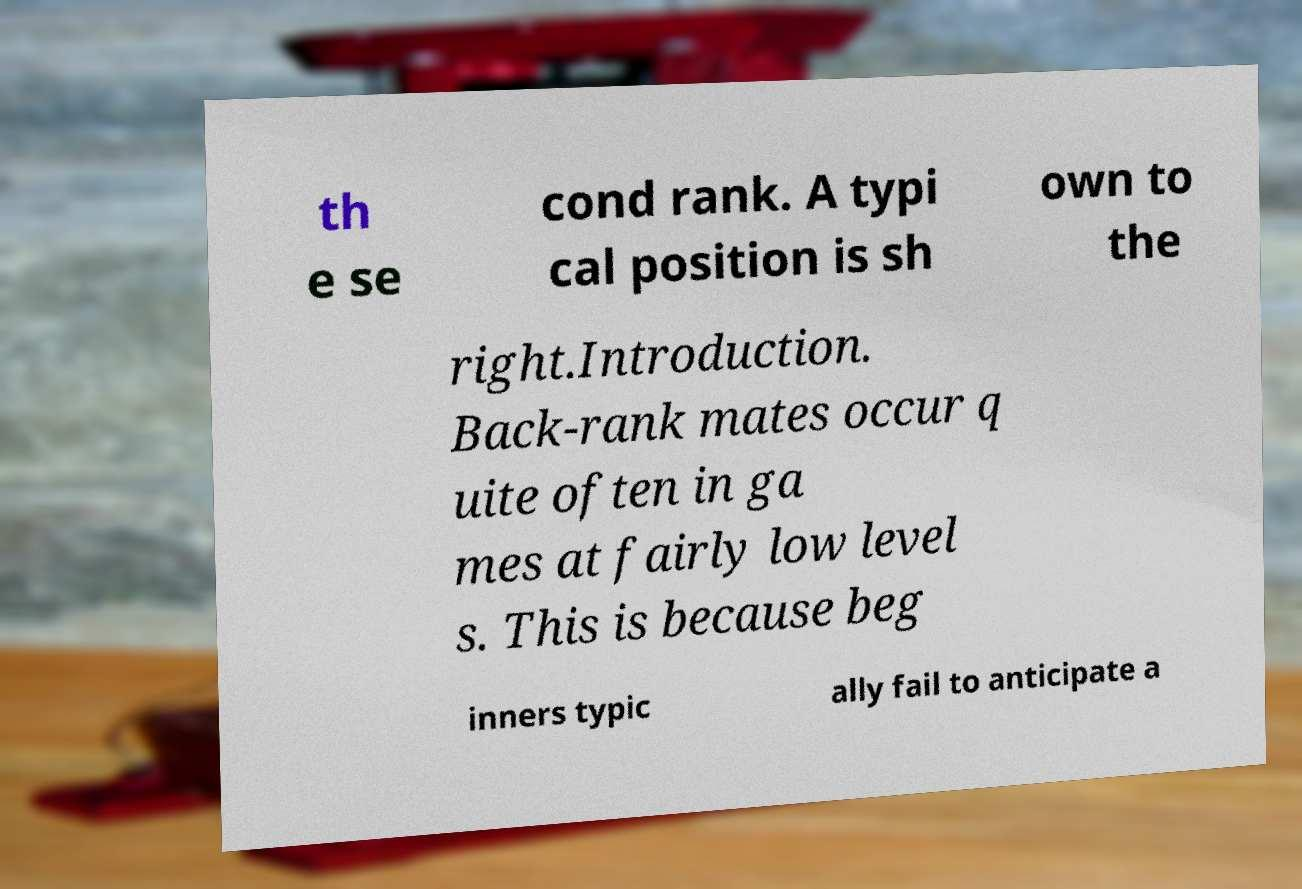For documentation purposes, I need the text within this image transcribed. Could you provide that? th e se cond rank. A typi cal position is sh own to the right.Introduction. Back-rank mates occur q uite often in ga mes at fairly low level s. This is because beg inners typic ally fail to anticipate a 